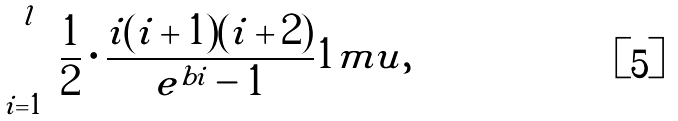Convert formula to latex. <formula><loc_0><loc_0><loc_500><loc_500>\sum _ { i = 1 } ^ { l } \frac { 1 } { 2 } \cdot \frac { i ( i + 1 ) ( i + 2 ) } { e ^ { b i } - 1 } { 1 m u } ,</formula> 